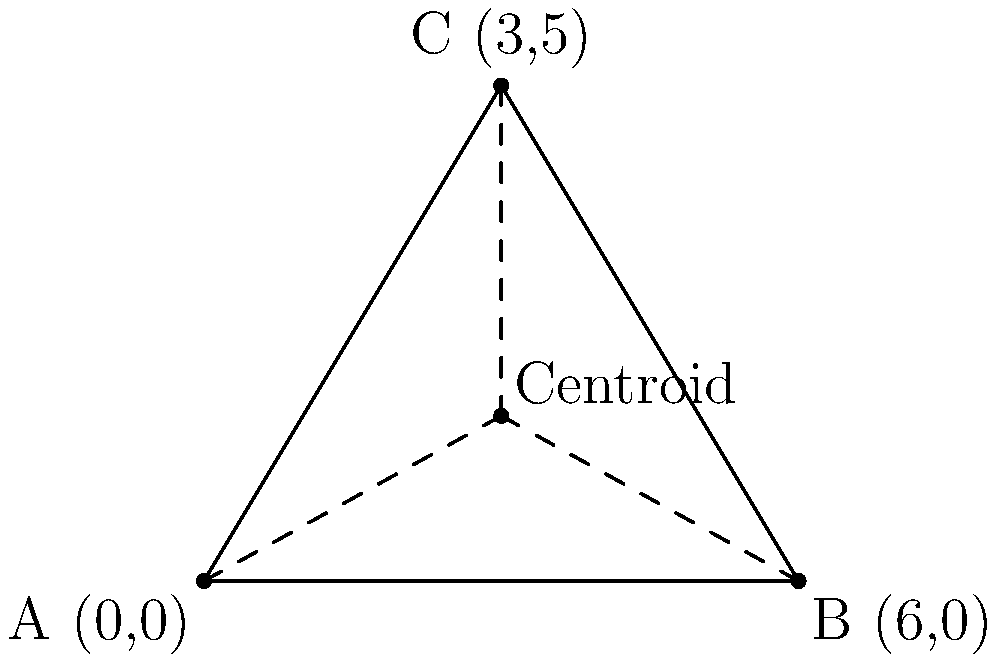A wildlife conservationist has recorded the sightings of three endangered species in a protected area. The locations are represented as points on a coordinate plane: Species A at (0,0), Species B at (6,0), and Species C at (3,5). What are the coordinates of the centroid of the triangle formed by these three sighting locations? To find the centroid of a triangle, we need to follow these steps:

1) The centroid of a triangle is located at the intersection of its medians. It divides each median in a 2:1 ratio, with the longer segment closer to the vertex.

2) The coordinates of the centroid can be calculated by averaging the x-coordinates and y-coordinates of the three vertices separately.

3) Given:
   Point A: (0,0)
   Point B: (6,0)
   Point C: (3,5)

4) To find the x-coordinate of the centroid:
   $x = \frac{x_A + x_B + x_C}{3} = \frac{0 + 6 + 3}{3} = \frac{9}{3} = 3$

5) To find the y-coordinate of the centroid:
   $y = \frac{y_A + y_B + y_C}{3} = \frac{0 + 0 + 5}{3} = \frac{5}{3}$

6) Therefore, the coordinates of the centroid are $(3, \frac{5}{3})$.
Answer: $(3, \frac{5}{3})$ 